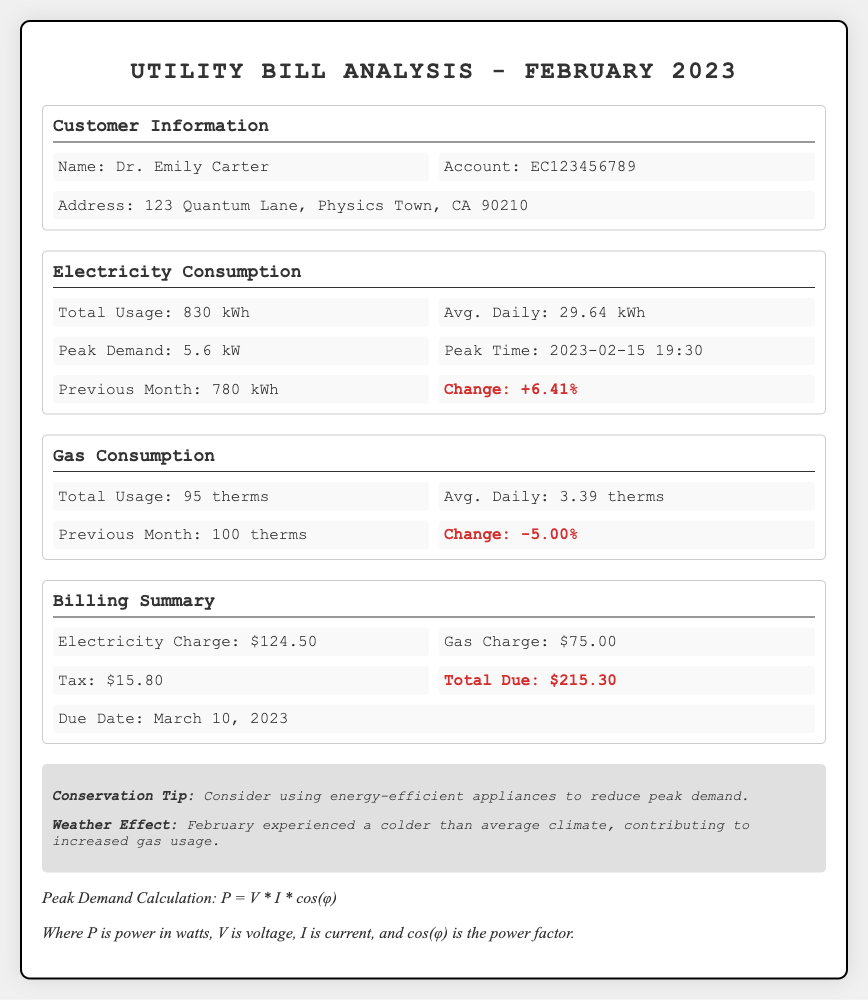What is the total electricity usage for February 2023? The total electricity usage for February 2023 is specified directly in the document.
Answer: 830 kWh What is the peak demand recorded in February 2023? The peak demand is highlighted in the electricity consumption section of the document.
Answer: 5.6 kW What was the average daily gas consumption? The average daily gas consumption is shown in the gas consumption section.
Answer: 3.39 therms What is the total due amount for the utility bill? The total due is summarized in the billing summary section of the document.
Answer: $215.30 What was the change in electricity consumption compared to the previous month? The change in electricity consumption is indicated in the electricity consumption section, with a percentage change shown.
Answer: +6.41% What is the due date for the total payment? The due date for the payment is presented in the billing summary section of the document.
Answer: March 10, 2023 What was the total gas usage for February 2023? The total gas usage is directly stated in the gas consumption section of the document.
Answer: 95 therms What conservation tip is provided in the document? The conservation tip aimed at reducing energy usage is noted in the notes section.
Answer: Consider using energy-efficient appliances to reduce peak demand What effect did the weather have on the gas usage? The impact of weather conditions on gas usage is mentioned in the notes section of the document.
Answer: February experienced a colder than average climate, contributing to increased gas usage 